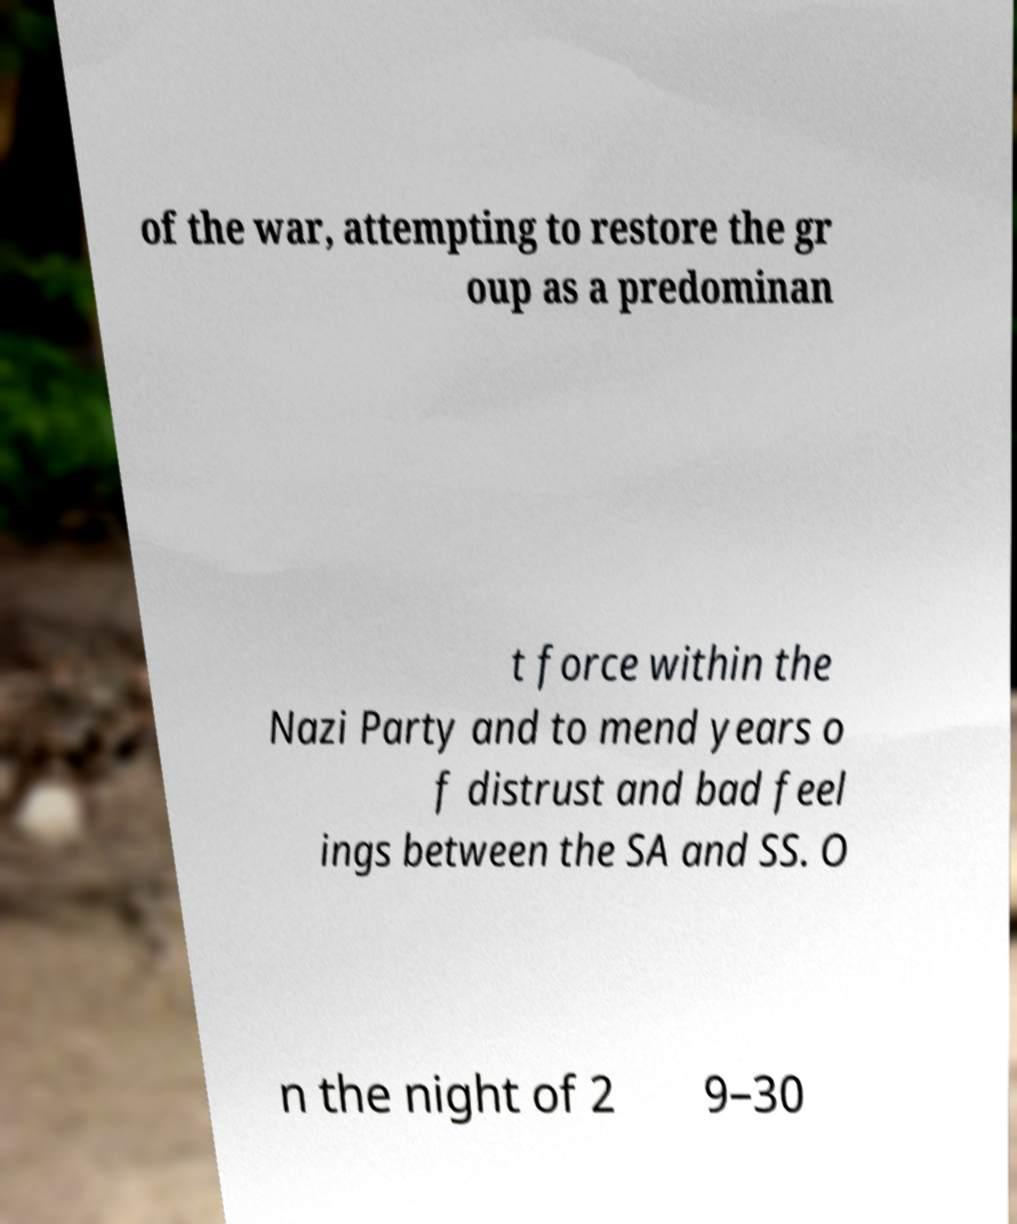I need the written content from this picture converted into text. Can you do that? of the war, attempting to restore the gr oup as a predominan t force within the Nazi Party and to mend years o f distrust and bad feel ings between the SA and SS. O n the night of 2 9–30 